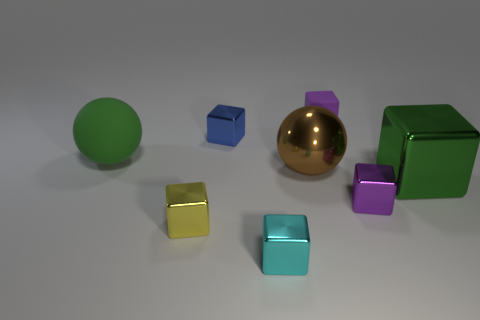Is the big matte object the same color as the big block?
Provide a succinct answer. Yes. There is another purple thing that is the same shape as the purple shiny thing; what is it made of?
Make the answer very short. Rubber. What number of rubber things are blue objects or yellow objects?
Give a very brief answer. 0. What is the shape of the small yellow thing that is the same material as the blue thing?
Offer a terse response. Cube. How many other large metallic things have the same shape as the yellow object?
Keep it short and to the point. 1. Do the green thing to the left of the cyan shiny object and the matte object that is right of the tiny cyan object have the same shape?
Your response must be concise. No. How many objects are either tiny cyan blocks or matte things in front of the small purple rubber cube?
Make the answer very short. 2. What shape is the object that is the same color as the large cube?
Your response must be concise. Sphere. What number of other green objects have the same size as the green metallic thing?
Offer a very short reply. 1. What number of gray things are large matte cubes or large metallic blocks?
Your response must be concise. 0. 